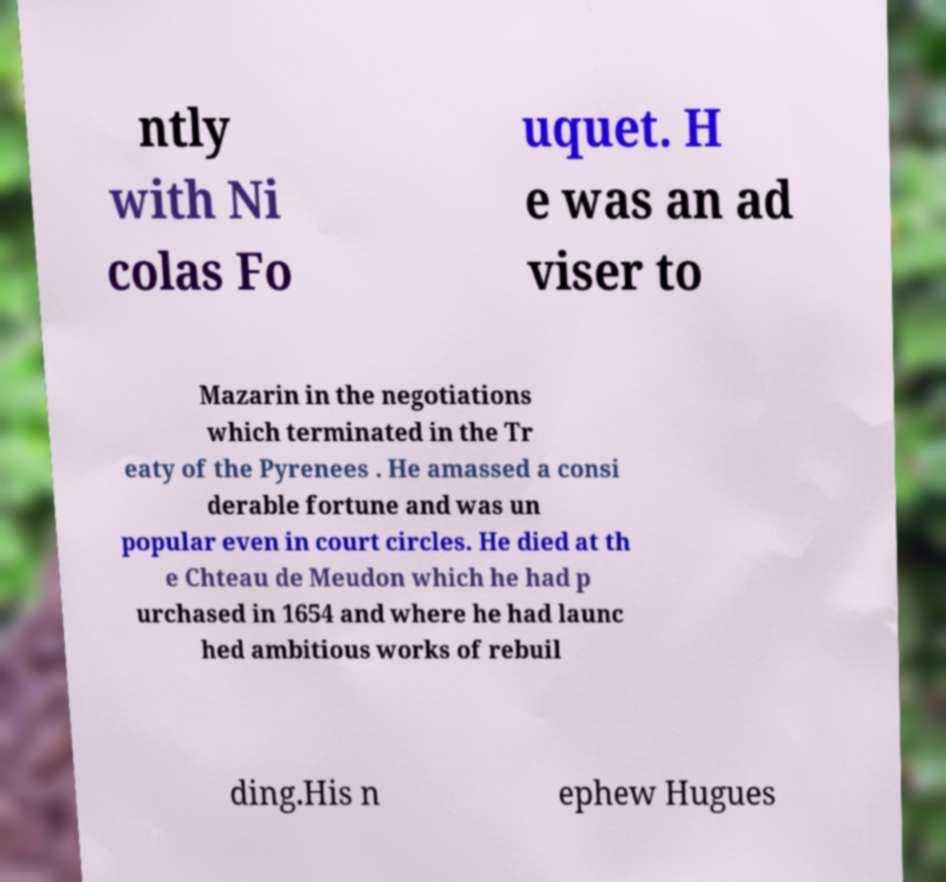Can you read and provide the text displayed in the image?This photo seems to have some interesting text. Can you extract and type it out for me? ntly with Ni colas Fo uquet. H e was an ad viser to Mazarin in the negotiations which terminated in the Tr eaty of the Pyrenees . He amassed a consi derable fortune and was un popular even in court circles. He died at th e Chteau de Meudon which he had p urchased in 1654 and where he had launc hed ambitious works of rebuil ding.His n ephew Hugues 